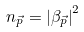Convert formula to latex. <formula><loc_0><loc_0><loc_500><loc_500>n _ { \vec { p } } = \left | \beta _ { \vec { p } } \right | ^ { 2 }</formula> 